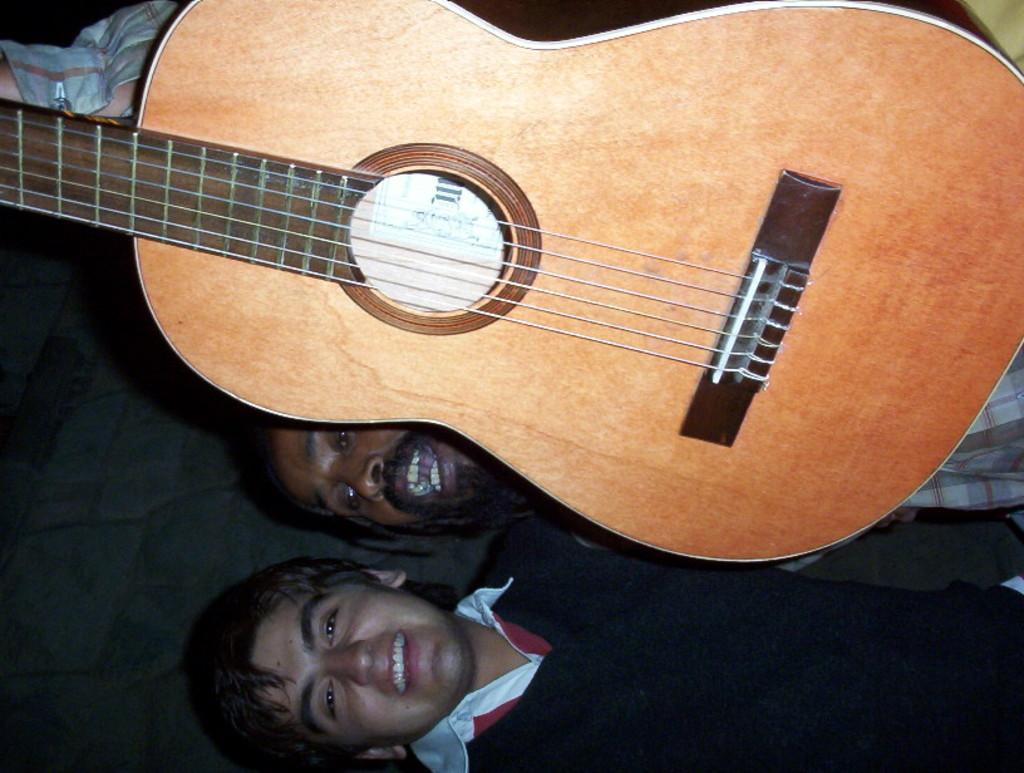Could you give a brief overview of what you see in this image? In this picture a guy is holding a guitar with one of his hand and beside him there is a black shirt guy. 